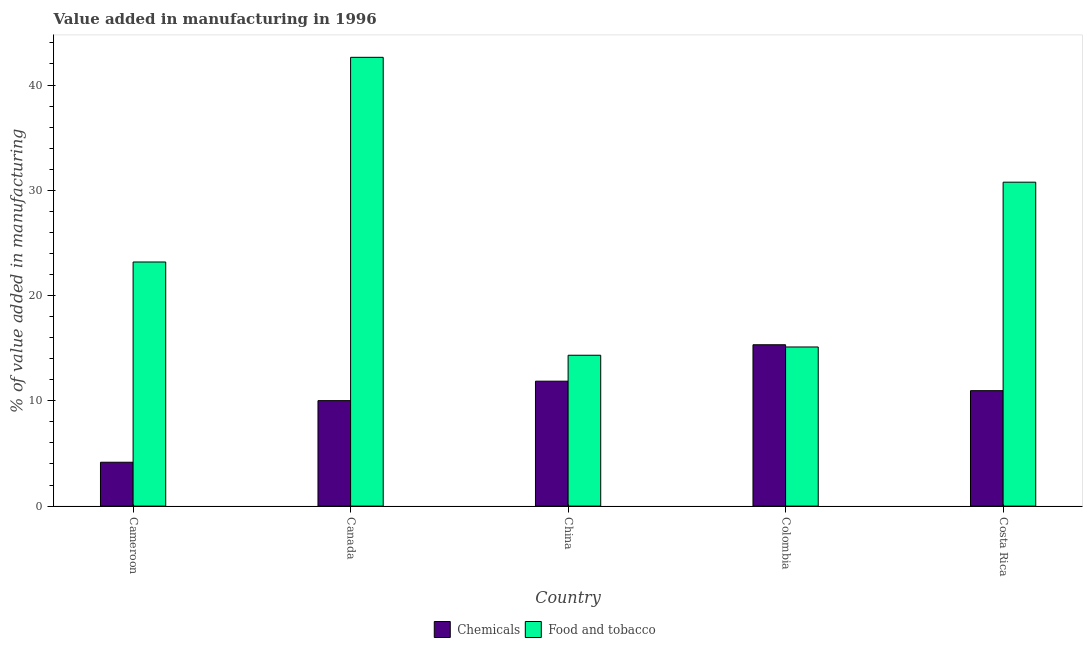How many groups of bars are there?
Give a very brief answer. 5. Are the number of bars on each tick of the X-axis equal?
Offer a terse response. Yes. What is the label of the 2nd group of bars from the left?
Make the answer very short. Canada. In how many cases, is the number of bars for a given country not equal to the number of legend labels?
Ensure brevity in your answer.  0. What is the value added by manufacturing food and tobacco in Costa Rica?
Your answer should be compact. 30.77. Across all countries, what is the maximum value added by manufacturing food and tobacco?
Keep it short and to the point. 42.63. Across all countries, what is the minimum value added by manufacturing food and tobacco?
Provide a succinct answer. 14.33. In which country was the value added by  manufacturing chemicals minimum?
Make the answer very short. Cameroon. What is the total value added by manufacturing food and tobacco in the graph?
Provide a short and direct response. 126.05. What is the difference between the value added by manufacturing food and tobacco in Canada and that in Costa Rica?
Ensure brevity in your answer.  11.86. What is the difference between the value added by manufacturing food and tobacco in Costa Rica and the value added by  manufacturing chemicals in Colombia?
Ensure brevity in your answer.  15.45. What is the average value added by  manufacturing chemicals per country?
Provide a succinct answer. 10.47. What is the difference between the value added by  manufacturing chemicals and value added by manufacturing food and tobacco in China?
Your answer should be very brief. -2.46. In how many countries, is the value added by manufacturing food and tobacco greater than 34 %?
Offer a very short reply. 1. What is the ratio of the value added by manufacturing food and tobacco in Cameroon to that in Canada?
Provide a short and direct response. 0.54. Is the difference between the value added by  manufacturing chemicals in Cameroon and Costa Rica greater than the difference between the value added by manufacturing food and tobacco in Cameroon and Costa Rica?
Give a very brief answer. Yes. What is the difference between the highest and the second highest value added by manufacturing food and tobacco?
Make the answer very short. 11.86. What is the difference between the highest and the lowest value added by manufacturing food and tobacco?
Offer a terse response. 28.3. In how many countries, is the value added by manufacturing food and tobacco greater than the average value added by manufacturing food and tobacco taken over all countries?
Provide a succinct answer. 2. Is the sum of the value added by  manufacturing chemicals in Canada and Colombia greater than the maximum value added by manufacturing food and tobacco across all countries?
Provide a short and direct response. No. What does the 1st bar from the left in Cameroon represents?
Your answer should be compact. Chemicals. What does the 1st bar from the right in Cameroon represents?
Offer a terse response. Food and tobacco. Are all the bars in the graph horizontal?
Keep it short and to the point. No. How many countries are there in the graph?
Ensure brevity in your answer.  5. Are the values on the major ticks of Y-axis written in scientific E-notation?
Offer a terse response. No. Does the graph contain any zero values?
Your response must be concise. No. How are the legend labels stacked?
Give a very brief answer. Horizontal. What is the title of the graph?
Your answer should be compact. Value added in manufacturing in 1996. Does "Underweight" appear as one of the legend labels in the graph?
Make the answer very short. No. What is the label or title of the Y-axis?
Your answer should be compact. % of value added in manufacturing. What is the % of value added in manufacturing of Chemicals in Cameroon?
Make the answer very short. 4.17. What is the % of value added in manufacturing in Food and tobacco in Cameroon?
Your answer should be compact. 23.19. What is the % of value added in manufacturing in Chemicals in Canada?
Provide a succinct answer. 10.02. What is the % of value added in manufacturing of Food and tobacco in Canada?
Give a very brief answer. 42.63. What is the % of value added in manufacturing in Chemicals in China?
Your answer should be very brief. 11.87. What is the % of value added in manufacturing in Food and tobacco in China?
Offer a very short reply. 14.33. What is the % of value added in manufacturing in Chemicals in Colombia?
Offer a terse response. 15.33. What is the % of value added in manufacturing in Food and tobacco in Colombia?
Make the answer very short. 15.12. What is the % of value added in manufacturing of Chemicals in Costa Rica?
Your answer should be compact. 10.97. What is the % of value added in manufacturing in Food and tobacco in Costa Rica?
Your answer should be very brief. 30.77. Across all countries, what is the maximum % of value added in manufacturing of Chemicals?
Offer a very short reply. 15.33. Across all countries, what is the maximum % of value added in manufacturing of Food and tobacco?
Keep it short and to the point. 42.63. Across all countries, what is the minimum % of value added in manufacturing in Chemicals?
Make the answer very short. 4.17. Across all countries, what is the minimum % of value added in manufacturing of Food and tobacco?
Provide a short and direct response. 14.33. What is the total % of value added in manufacturing in Chemicals in the graph?
Give a very brief answer. 52.35. What is the total % of value added in manufacturing in Food and tobacco in the graph?
Make the answer very short. 126.05. What is the difference between the % of value added in manufacturing of Chemicals in Cameroon and that in Canada?
Make the answer very short. -5.85. What is the difference between the % of value added in manufacturing in Food and tobacco in Cameroon and that in Canada?
Keep it short and to the point. -19.44. What is the difference between the % of value added in manufacturing of Chemicals in Cameroon and that in China?
Make the answer very short. -7.7. What is the difference between the % of value added in manufacturing of Food and tobacco in Cameroon and that in China?
Your answer should be compact. 8.86. What is the difference between the % of value added in manufacturing of Chemicals in Cameroon and that in Colombia?
Keep it short and to the point. -11.16. What is the difference between the % of value added in manufacturing of Food and tobacco in Cameroon and that in Colombia?
Provide a succinct answer. 8.07. What is the difference between the % of value added in manufacturing of Chemicals in Cameroon and that in Costa Rica?
Ensure brevity in your answer.  -6.8. What is the difference between the % of value added in manufacturing of Food and tobacco in Cameroon and that in Costa Rica?
Offer a terse response. -7.58. What is the difference between the % of value added in manufacturing in Chemicals in Canada and that in China?
Make the answer very short. -1.85. What is the difference between the % of value added in manufacturing of Food and tobacco in Canada and that in China?
Provide a succinct answer. 28.3. What is the difference between the % of value added in manufacturing of Chemicals in Canada and that in Colombia?
Provide a short and direct response. -5.31. What is the difference between the % of value added in manufacturing of Food and tobacco in Canada and that in Colombia?
Make the answer very short. 27.52. What is the difference between the % of value added in manufacturing of Chemicals in Canada and that in Costa Rica?
Give a very brief answer. -0.95. What is the difference between the % of value added in manufacturing in Food and tobacco in Canada and that in Costa Rica?
Keep it short and to the point. 11.86. What is the difference between the % of value added in manufacturing in Chemicals in China and that in Colombia?
Your response must be concise. -3.46. What is the difference between the % of value added in manufacturing of Food and tobacco in China and that in Colombia?
Keep it short and to the point. -0.79. What is the difference between the % of value added in manufacturing of Chemicals in China and that in Costa Rica?
Your answer should be very brief. 0.9. What is the difference between the % of value added in manufacturing in Food and tobacco in China and that in Costa Rica?
Keep it short and to the point. -16.44. What is the difference between the % of value added in manufacturing of Chemicals in Colombia and that in Costa Rica?
Your response must be concise. 4.36. What is the difference between the % of value added in manufacturing of Food and tobacco in Colombia and that in Costa Rica?
Ensure brevity in your answer.  -15.66. What is the difference between the % of value added in manufacturing in Chemicals in Cameroon and the % of value added in manufacturing in Food and tobacco in Canada?
Make the answer very short. -38.47. What is the difference between the % of value added in manufacturing in Chemicals in Cameroon and the % of value added in manufacturing in Food and tobacco in China?
Provide a succinct answer. -10.17. What is the difference between the % of value added in manufacturing of Chemicals in Cameroon and the % of value added in manufacturing of Food and tobacco in Colombia?
Give a very brief answer. -10.95. What is the difference between the % of value added in manufacturing of Chemicals in Cameroon and the % of value added in manufacturing of Food and tobacco in Costa Rica?
Give a very brief answer. -26.61. What is the difference between the % of value added in manufacturing of Chemicals in Canada and the % of value added in manufacturing of Food and tobacco in China?
Provide a short and direct response. -4.31. What is the difference between the % of value added in manufacturing in Chemicals in Canada and the % of value added in manufacturing in Food and tobacco in Colombia?
Provide a short and direct response. -5.1. What is the difference between the % of value added in manufacturing of Chemicals in Canada and the % of value added in manufacturing of Food and tobacco in Costa Rica?
Your answer should be very brief. -20.75. What is the difference between the % of value added in manufacturing in Chemicals in China and the % of value added in manufacturing in Food and tobacco in Colombia?
Make the answer very short. -3.25. What is the difference between the % of value added in manufacturing in Chemicals in China and the % of value added in manufacturing in Food and tobacco in Costa Rica?
Ensure brevity in your answer.  -18.91. What is the difference between the % of value added in manufacturing of Chemicals in Colombia and the % of value added in manufacturing of Food and tobacco in Costa Rica?
Offer a very short reply. -15.45. What is the average % of value added in manufacturing in Chemicals per country?
Make the answer very short. 10.47. What is the average % of value added in manufacturing in Food and tobacco per country?
Provide a succinct answer. 25.21. What is the difference between the % of value added in manufacturing of Chemicals and % of value added in manufacturing of Food and tobacco in Cameroon?
Offer a terse response. -19.02. What is the difference between the % of value added in manufacturing of Chemicals and % of value added in manufacturing of Food and tobacco in Canada?
Keep it short and to the point. -32.62. What is the difference between the % of value added in manufacturing of Chemicals and % of value added in manufacturing of Food and tobacco in China?
Ensure brevity in your answer.  -2.46. What is the difference between the % of value added in manufacturing of Chemicals and % of value added in manufacturing of Food and tobacco in Colombia?
Keep it short and to the point. 0.21. What is the difference between the % of value added in manufacturing of Chemicals and % of value added in manufacturing of Food and tobacco in Costa Rica?
Provide a short and direct response. -19.81. What is the ratio of the % of value added in manufacturing in Chemicals in Cameroon to that in Canada?
Your answer should be compact. 0.42. What is the ratio of the % of value added in manufacturing in Food and tobacco in Cameroon to that in Canada?
Your response must be concise. 0.54. What is the ratio of the % of value added in manufacturing in Chemicals in Cameroon to that in China?
Make the answer very short. 0.35. What is the ratio of the % of value added in manufacturing of Food and tobacco in Cameroon to that in China?
Offer a very short reply. 1.62. What is the ratio of the % of value added in manufacturing in Chemicals in Cameroon to that in Colombia?
Make the answer very short. 0.27. What is the ratio of the % of value added in manufacturing in Food and tobacco in Cameroon to that in Colombia?
Ensure brevity in your answer.  1.53. What is the ratio of the % of value added in manufacturing in Chemicals in Cameroon to that in Costa Rica?
Ensure brevity in your answer.  0.38. What is the ratio of the % of value added in manufacturing of Food and tobacco in Cameroon to that in Costa Rica?
Offer a terse response. 0.75. What is the ratio of the % of value added in manufacturing of Chemicals in Canada to that in China?
Your answer should be compact. 0.84. What is the ratio of the % of value added in manufacturing in Food and tobacco in Canada to that in China?
Ensure brevity in your answer.  2.97. What is the ratio of the % of value added in manufacturing of Chemicals in Canada to that in Colombia?
Keep it short and to the point. 0.65. What is the ratio of the % of value added in manufacturing of Food and tobacco in Canada to that in Colombia?
Provide a short and direct response. 2.82. What is the ratio of the % of value added in manufacturing in Chemicals in Canada to that in Costa Rica?
Provide a short and direct response. 0.91. What is the ratio of the % of value added in manufacturing in Food and tobacco in Canada to that in Costa Rica?
Keep it short and to the point. 1.39. What is the ratio of the % of value added in manufacturing of Chemicals in China to that in Colombia?
Make the answer very short. 0.77. What is the ratio of the % of value added in manufacturing of Food and tobacco in China to that in Colombia?
Make the answer very short. 0.95. What is the ratio of the % of value added in manufacturing of Chemicals in China to that in Costa Rica?
Give a very brief answer. 1.08. What is the ratio of the % of value added in manufacturing in Food and tobacco in China to that in Costa Rica?
Give a very brief answer. 0.47. What is the ratio of the % of value added in manufacturing in Chemicals in Colombia to that in Costa Rica?
Your answer should be very brief. 1.4. What is the ratio of the % of value added in manufacturing in Food and tobacco in Colombia to that in Costa Rica?
Provide a succinct answer. 0.49. What is the difference between the highest and the second highest % of value added in manufacturing of Chemicals?
Offer a very short reply. 3.46. What is the difference between the highest and the second highest % of value added in manufacturing in Food and tobacco?
Provide a succinct answer. 11.86. What is the difference between the highest and the lowest % of value added in manufacturing in Chemicals?
Give a very brief answer. 11.16. What is the difference between the highest and the lowest % of value added in manufacturing in Food and tobacco?
Your answer should be compact. 28.3. 